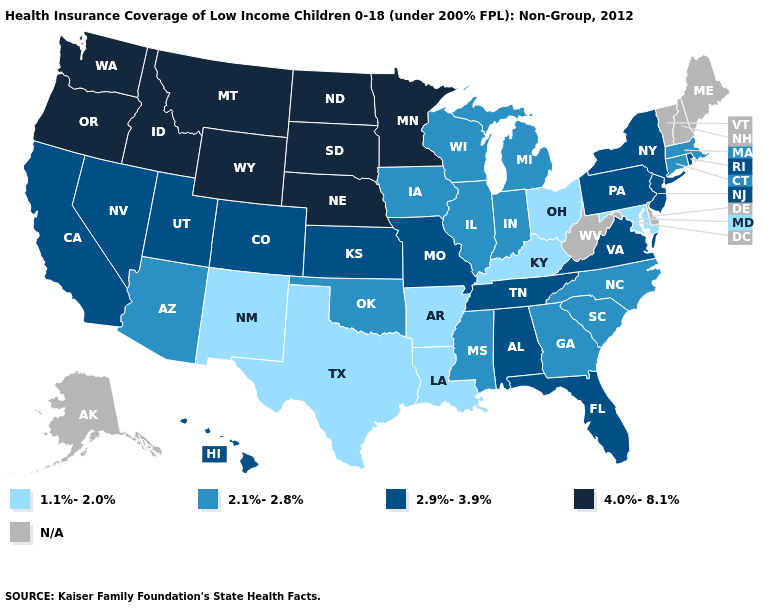Which states have the highest value in the USA?
Be succinct. Idaho, Minnesota, Montana, Nebraska, North Dakota, Oregon, South Dakota, Washington, Wyoming. Is the legend a continuous bar?
Concise answer only. No. What is the lowest value in states that border Connecticut?
Write a very short answer. 2.1%-2.8%. Name the states that have a value in the range N/A?
Answer briefly. Alaska, Delaware, Maine, New Hampshire, Vermont, West Virginia. Name the states that have a value in the range 4.0%-8.1%?
Write a very short answer. Idaho, Minnesota, Montana, Nebraska, North Dakota, Oregon, South Dakota, Washington, Wyoming. What is the highest value in the South ?
Answer briefly. 2.9%-3.9%. What is the value of Wyoming?
Keep it brief. 4.0%-8.1%. What is the value of New Jersey?
Quick response, please. 2.9%-3.9%. Name the states that have a value in the range N/A?
Write a very short answer. Alaska, Delaware, Maine, New Hampshire, Vermont, West Virginia. Does Georgia have the lowest value in the South?
Give a very brief answer. No. What is the value of North Dakota?
Short answer required. 4.0%-8.1%. What is the value of Pennsylvania?
Answer briefly. 2.9%-3.9%. 